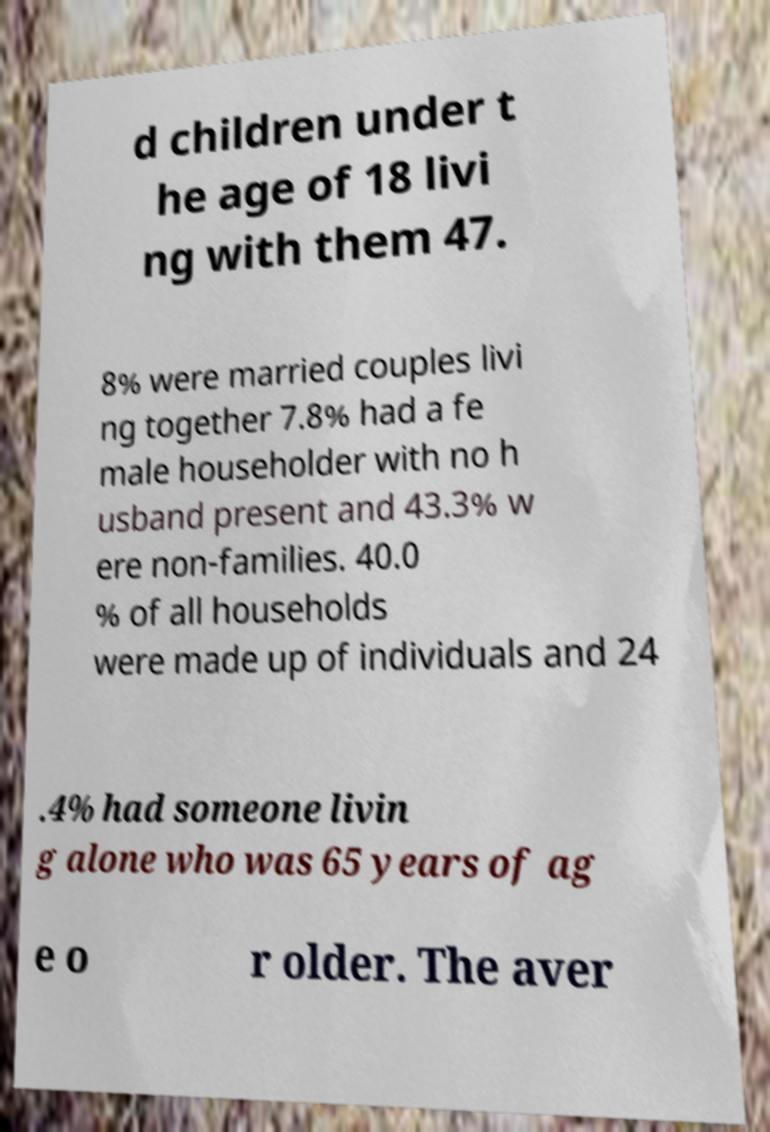What messages or text are displayed in this image? I need them in a readable, typed format. d children under t he age of 18 livi ng with them 47. 8% were married couples livi ng together 7.8% had a fe male householder with no h usband present and 43.3% w ere non-families. 40.0 % of all households were made up of individuals and 24 .4% had someone livin g alone who was 65 years of ag e o r older. The aver 